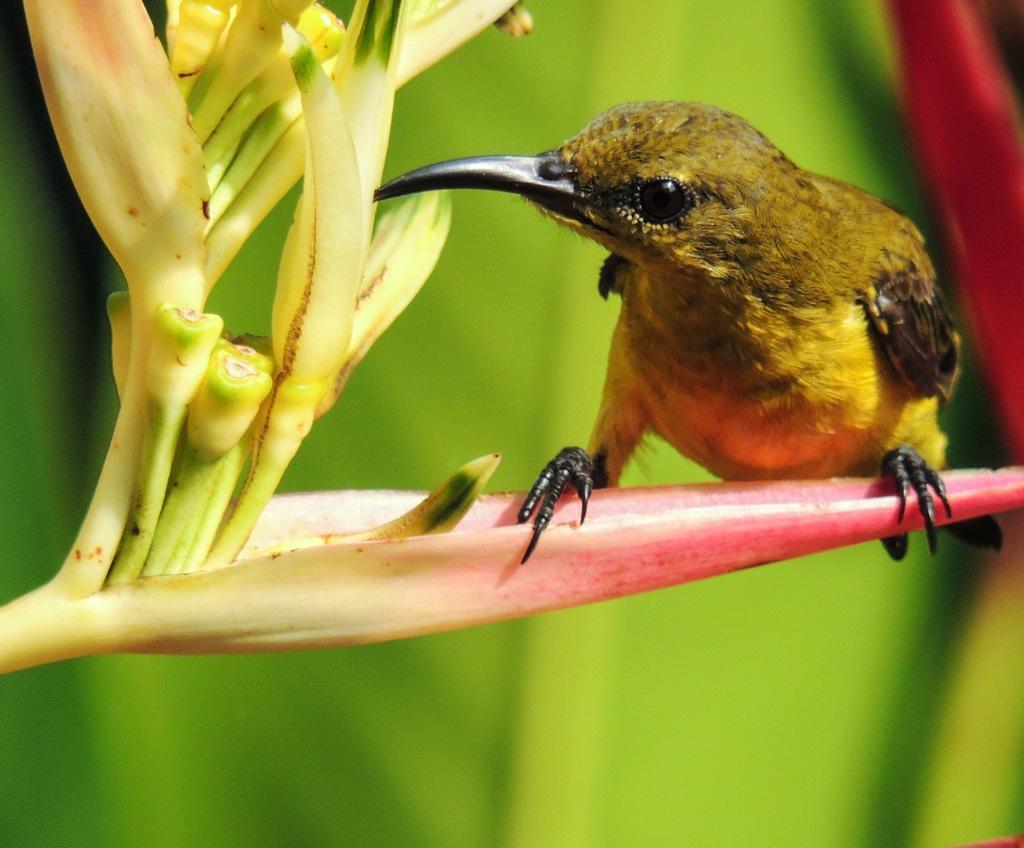In one or two sentences, can you explain what this image depicts? In this image we can see there is a bird on the flower. 